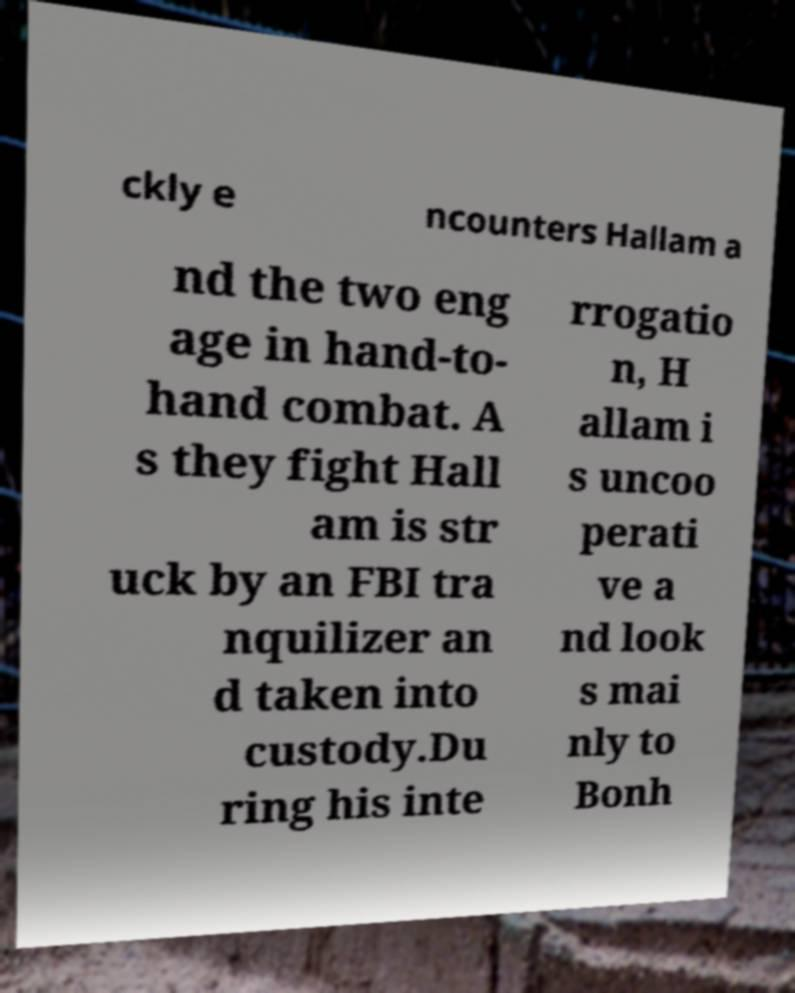I need the written content from this picture converted into text. Can you do that? ckly e ncounters Hallam a nd the two eng age in hand-to- hand combat. A s they fight Hall am is str uck by an FBI tra nquilizer an d taken into custody.Du ring his inte rrogatio n, H allam i s uncoo perati ve a nd look s mai nly to Bonh 